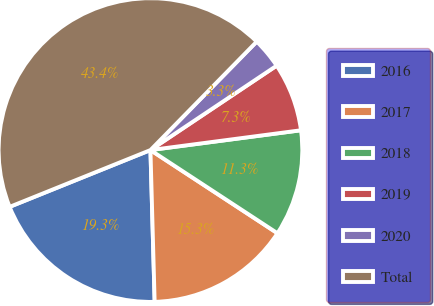Convert chart to OTSL. <chart><loc_0><loc_0><loc_500><loc_500><pie_chart><fcel>2016<fcel>2017<fcel>2018<fcel>2019<fcel>2020<fcel>Total<nl><fcel>19.34%<fcel>15.33%<fcel>11.31%<fcel>7.3%<fcel>3.28%<fcel>43.44%<nl></chart> 